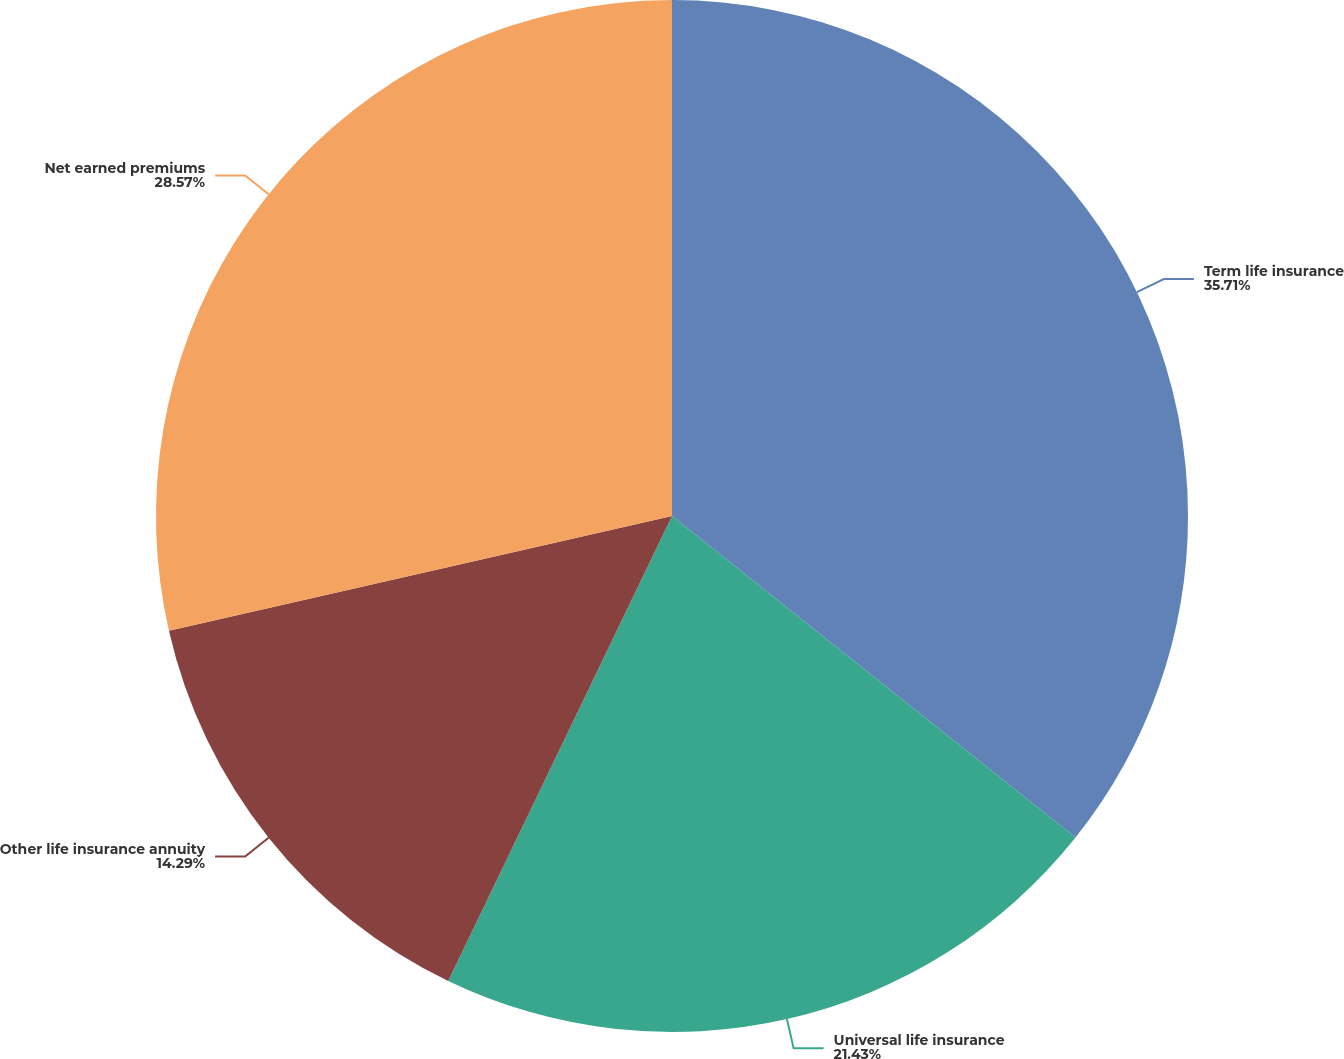<chart> <loc_0><loc_0><loc_500><loc_500><pie_chart><fcel>Term life insurance<fcel>Universal life insurance<fcel>Other life insurance annuity<fcel>Net earned premiums<nl><fcel>35.71%<fcel>21.43%<fcel>14.29%<fcel>28.57%<nl></chart> 